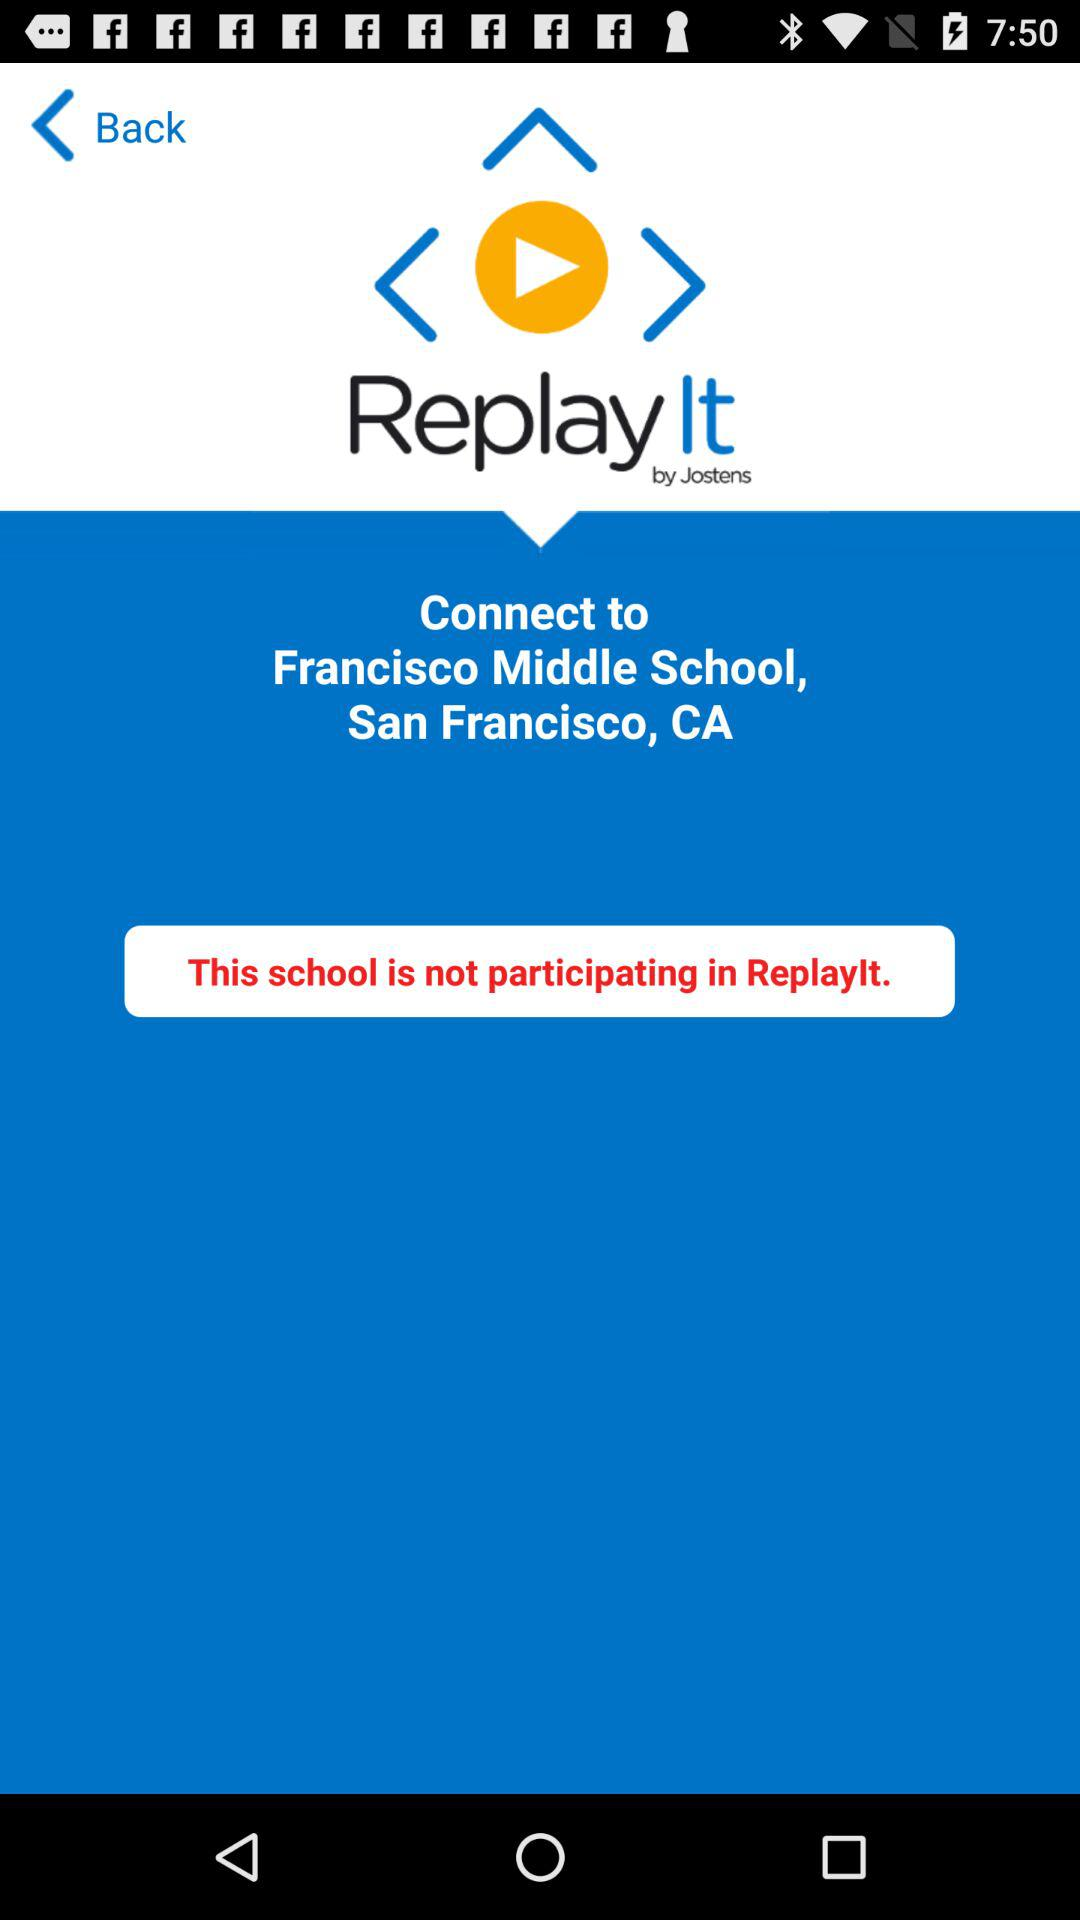What is the name of the application? The name of the application is "ReplayIt". 